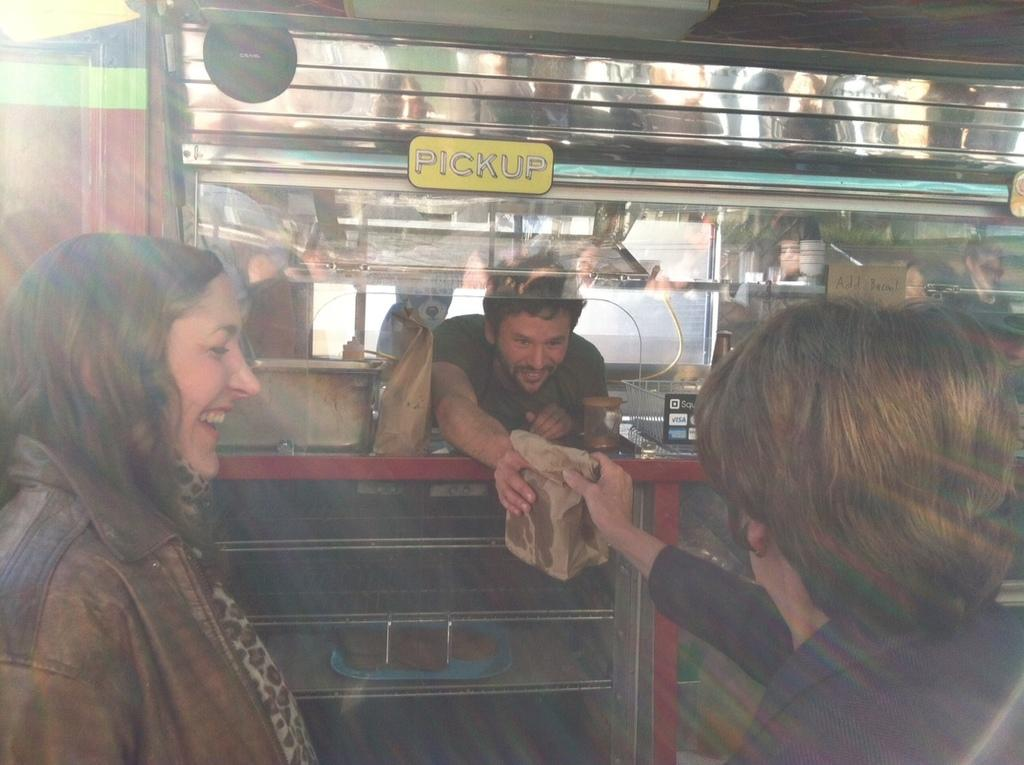How many people are in the image? There are persons standing in the image. What is one of the persons holding in their hands? One of the persons is holding a paper cover in their hands. What can be seen in the background of the image? There is a food truck and information boards in the background of the image. What type of instrument is the person playing in the image? There is no instrument present in the image; the person is holding a paper cover. What is the ring used for in the image? There is no ring present in the image. 